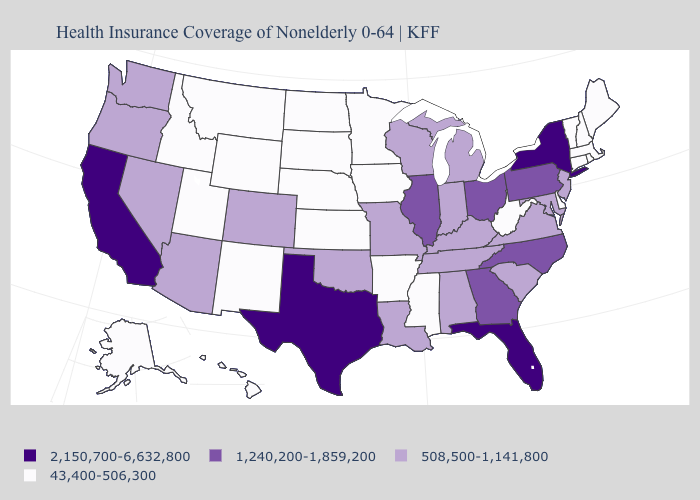What is the highest value in the USA?
Short answer required. 2,150,700-6,632,800. Does Rhode Island have a lower value than Massachusetts?
Short answer required. No. What is the value of Nebraska?
Keep it brief. 43,400-506,300. Which states have the lowest value in the USA?
Be succinct. Alaska, Arkansas, Connecticut, Delaware, Hawaii, Idaho, Iowa, Kansas, Maine, Massachusetts, Minnesota, Mississippi, Montana, Nebraska, New Hampshire, New Mexico, North Dakota, Rhode Island, South Dakota, Utah, Vermont, West Virginia, Wyoming. Name the states that have a value in the range 508,500-1,141,800?
Keep it brief. Alabama, Arizona, Colorado, Indiana, Kentucky, Louisiana, Maryland, Michigan, Missouri, Nevada, New Jersey, Oklahoma, Oregon, South Carolina, Tennessee, Virginia, Washington, Wisconsin. Does Oregon have a higher value than Arkansas?
Quick response, please. Yes. Does New Hampshire have the highest value in the Northeast?
Be succinct. No. Does Oklahoma have the lowest value in the USA?
Answer briefly. No. Which states have the lowest value in the USA?
Give a very brief answer. Alaska, Arkansas, Connecticut, Delaware, Hawaii, Idaho, Iowa, Kansas, Maine, Massachusetts, Minnesota, Mississippi, Montana, Nebraska, New Hampshire, New Mexico, North Dakota, Rhode Island, South Dakota, Utah, Vermont, West Virginia, Wyoming. Does Wisconsin have the lowest value in the MidWest?
Concise answer only. No. What is the lowest value in states that border New York?
Write a very short answer. 43,400-506,300. What is the lowest value in states that border Colorado?
Give a very brief answer. 43,400-506,300. Name the states that have a value in the range 43,400-506,300?
Answer briefly. Alaska, Arkansas, Connecticut, Delaware, Hawaii, Idaho, Iowa, Kansas, Maine, Massachusetts, Minnesota, Mississippi, Montana, Nebraska, New Hampshire, New Mexico, North Dakota, Rhode Island, South Dakota, Utah, Vermont, West Virginia, Wyoming. Name the states that have a value in the range 1,240,200-1,859,200?
Be succinct. Georgia, Illinois, North Carolina, Ohio, Pennsylvania. What is the value of Wisconsin?
Concise answer only. 508,500-1,141,800. 